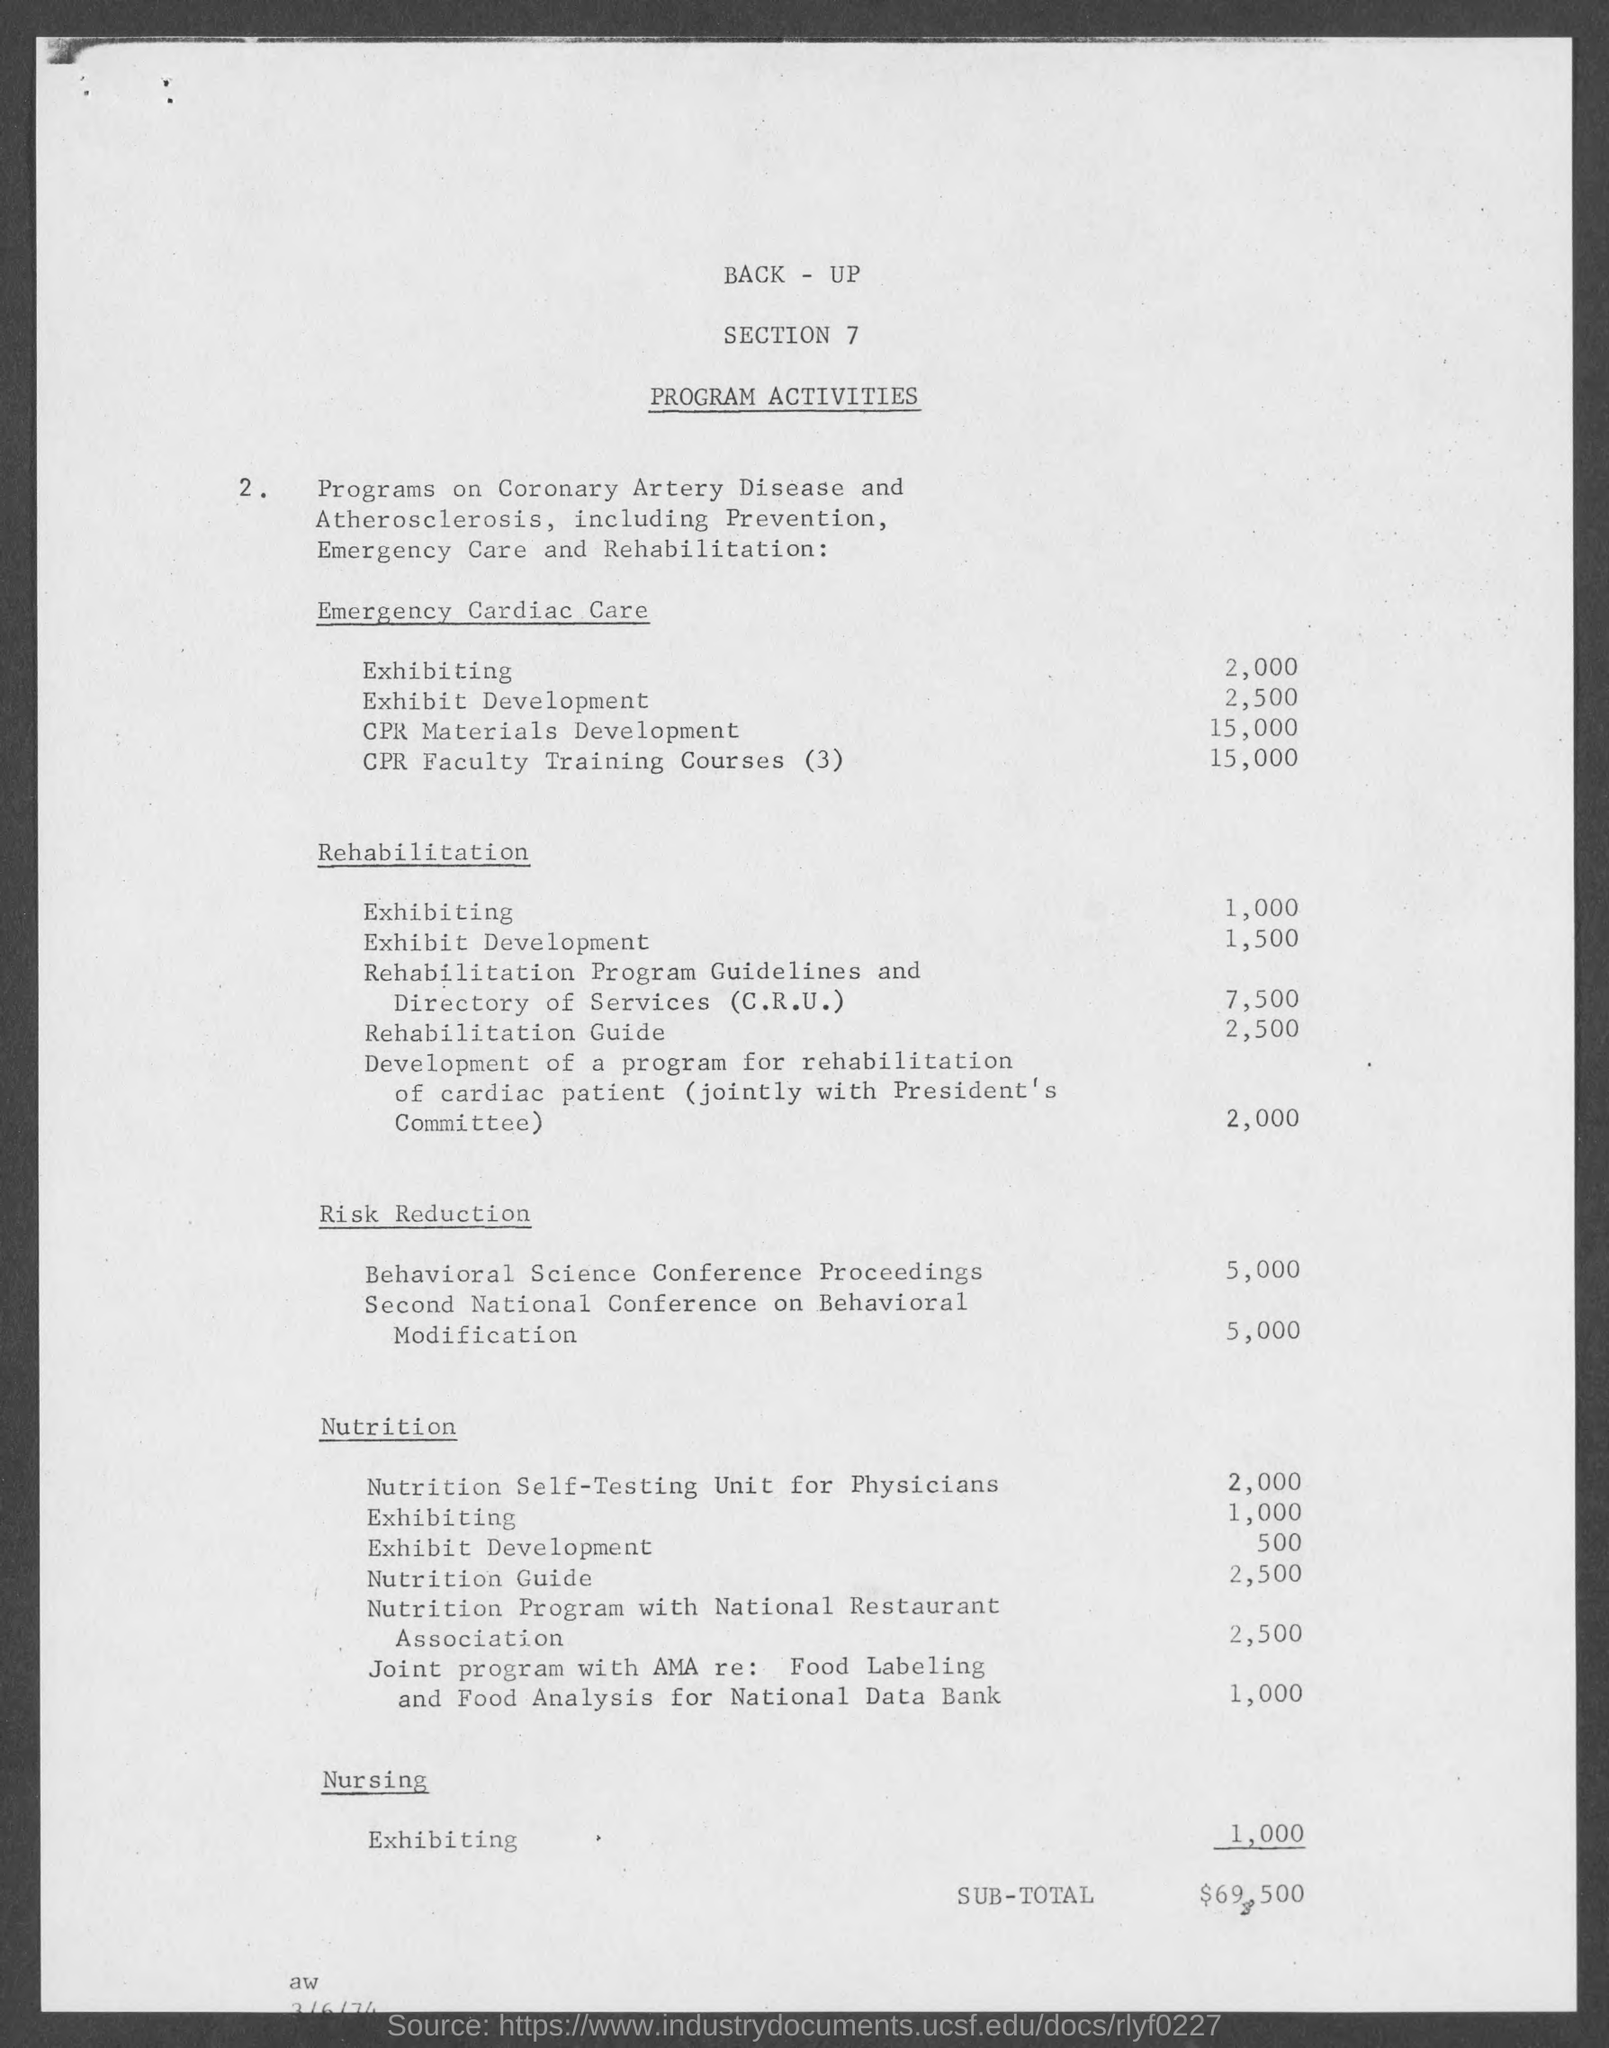Specify some key components in this picture. There are 1,000 exhibiting opportunities in nursing. There were 1,000 instances of exhibiting in rehabilitation. As of today, there are approximately 1,500 exhibit developments in rehabilitation. There are 2,500 Rehabilitation Guides in the Rehabilitation process. There are 2,500 exhibit development projects in emergency cardiac care. 